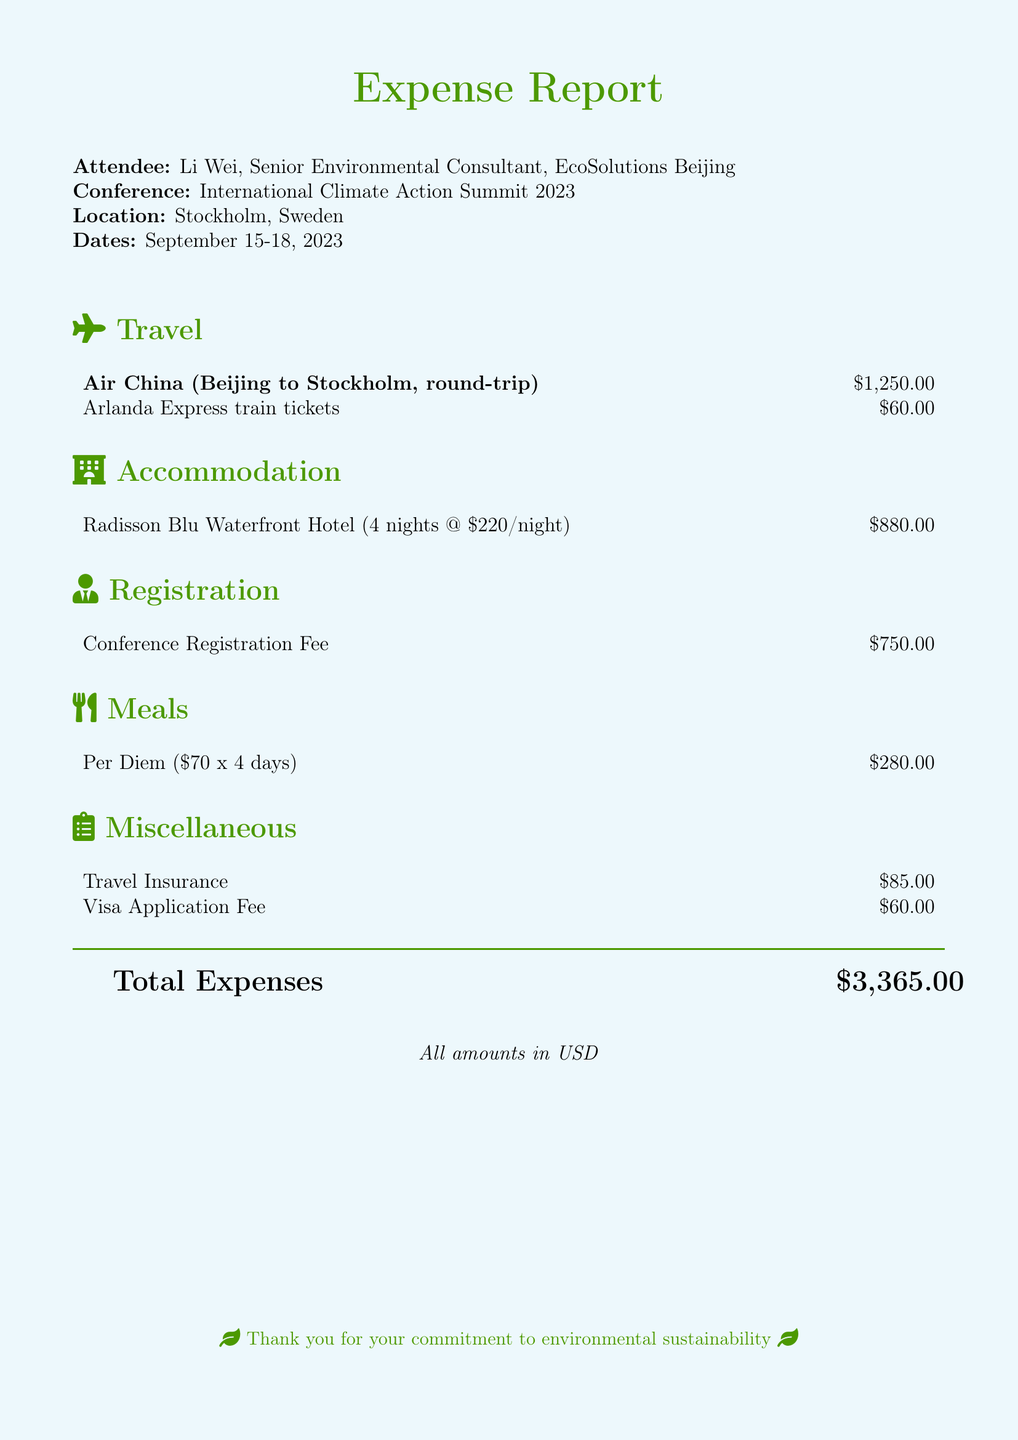What is the total amount of travel costs? The travel costs include the round-trip airline ticket and train tickets, totaling $1,250.00 + $60.00 = $1,310.00.
Answer: $1,310.00 Who is the attendee of the conference? The document specifies the attendee's name and title, which is Li Wei, Senior Environmental Consultant.
Answer: Li Wei What is the location of the conference? The document clearly states the conference's location as Stockholm, Sweden.
Answer: Stockholm, Sweden What is the duration of the stay at the hotel? The accommodation section mentions the number of nights stayed at the hotel, which is 4 nights.
Answer: 4 nights What is the total registration fee for the conference? The registration fee mentioned in the document is $750.00.
Answer: $750.00 How much is the daily per diem for meals? The document indicates that the per diem is $70 per day.
Answer: $70 What is the miscellaneous expense for travel insurance? The miscellaneous section specifies that the travel insurance cost is $85.00.
Answer: $85.00 What is the total expense reported in the document? Total expenses are calculated as shown at the end of the document, summing all expenses to $3,365.00.
Answer: $3,365.00 Which hotel was used for accommodation? The accommodation section lists the hotel used as Radisson Blu Waterfront Hotel.
Answer: Radisson Blu Waterfront Hotel 